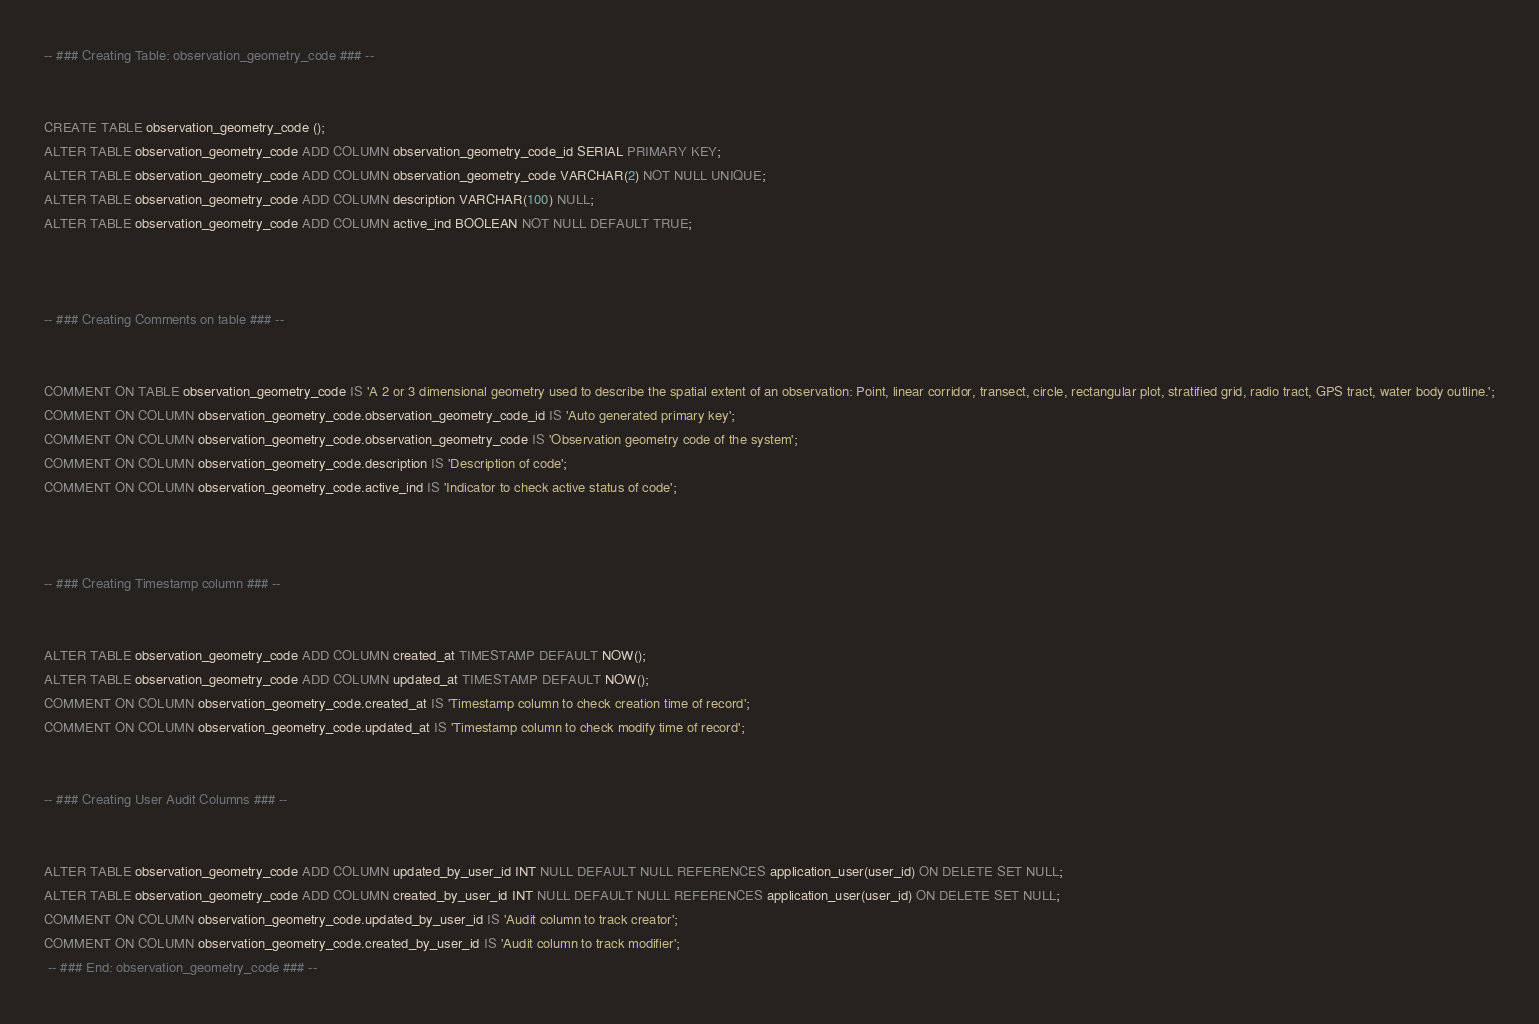<code> <loc_0><loc_0><loc_500><loc_500><_SQL_>-- ### Creating Table: observation_geometry_code ### --

        
CREATE TABLE observation_geometry_code ();
ALTER TABLE observation_geometry_code ADD COLUMN observation_geometry_code_id SERIAL PRIMARY KEY;
ALTER TABLE observation_geometry_code ADD COLUMN observation_geometry_code VARCHAR(2) NOT NULL UNIQUE;
ALTER TABLE observation_geometry_code ADD COLUMN description VARCHAR(100) NULL;
ALTER TABLE observation_geometry_code ADD COLUMN active_ind BOOLEAN NOT NULL DEFAULT TRUE;


        
-- ### Creating Comments on table ### --

        
COMMENT ON TABLE observation_geometry_code IS 'A 2 or 3 dimensional geometry used to describe the spatial extent of an observation: Point, linear corridor, transect, circle, rectangular plot, stratified grid, radio tract, GPS tract, water body outline.';
COMMENT ON COLUMN observation_geometry_code.observation_geometry_code_id IS 'Auto generated primary key';
COMMENT ON COLUMN observation_geometry_code.observation_geometry_code IS 'Observation geometry code of the system';
COMMENT ON COLUMN observation_geometry_code.description IS 'Description of code';
COMMENT ON COLUMN observation_geometry_code.active_ind IS 'Indicator to check active status of code';


        
-- ### Creating Timestamp column ### --

        
ALTER TABLE observation_geometry_code ADD COLUMN created_at TIMESTAMP DEFAULT NOW();
ALTER TABLE observation_geometry_code ADD COLUMN updated_at TIMESTAMP DEFAULT NOW();
COMMENT ON COLUMN observation_geometry_code.created_at IS 'Timestamp column to check creation time of record';
COMMENT ON COLUMN observation_geometry_code.updated_at IS 'Timestamp column to check modify time of record';

        
-- ### Creating User Audit Columns ### --

        
ALTER TABLE observation_geometry_code ADD COLUMN updated_by_user_id INT NULL DEFAULT NULL REFERENCES application_user(user_id) ON DELETE SET NULL;
ALTER TABLE observation_geometry_code ADD COLUMN created_by_user_id INT NULL DEFAULT NULL REFERENCES application_user(user_id) ON DELETE SET NULL;
COMMENT ON COLUMN observation_geometry_code.updated_by_user_id IS 'Audit column to track creator';
COMMENT ON COLUMN observation_geometry_code.created_by_user_id IS 'Audit column to track modifier';
 -- ### End: observation_geometry_code ### --
</code> 